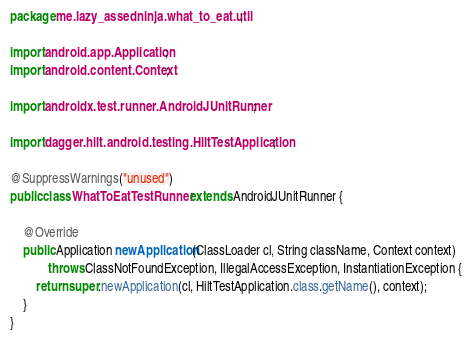Convert code to text. <code><loc_0><loc_0><loc_500><loc_500><_Java_>package me.lazy_assedninja.what_to_eat.util;

import android.app.Application;
import android.content.Context;

import androidx.test.runner.AndroidJUnitRunner;

import dagger.hilt.android.testing.HiltTestApplication;

@SuppressWarnings("unused")
public class WhatToEatTestRunner extends AndroidJUnitRunner {

    @Override
    public Application newApplication(ClassLoader cl, String className, Context context)
            throws ClassNotFoundException, IllegalAccessException, InstantiationException {
        return super.newApplication(cl, HiltTestApplication.class.getName(), context);
    }
}</code> 